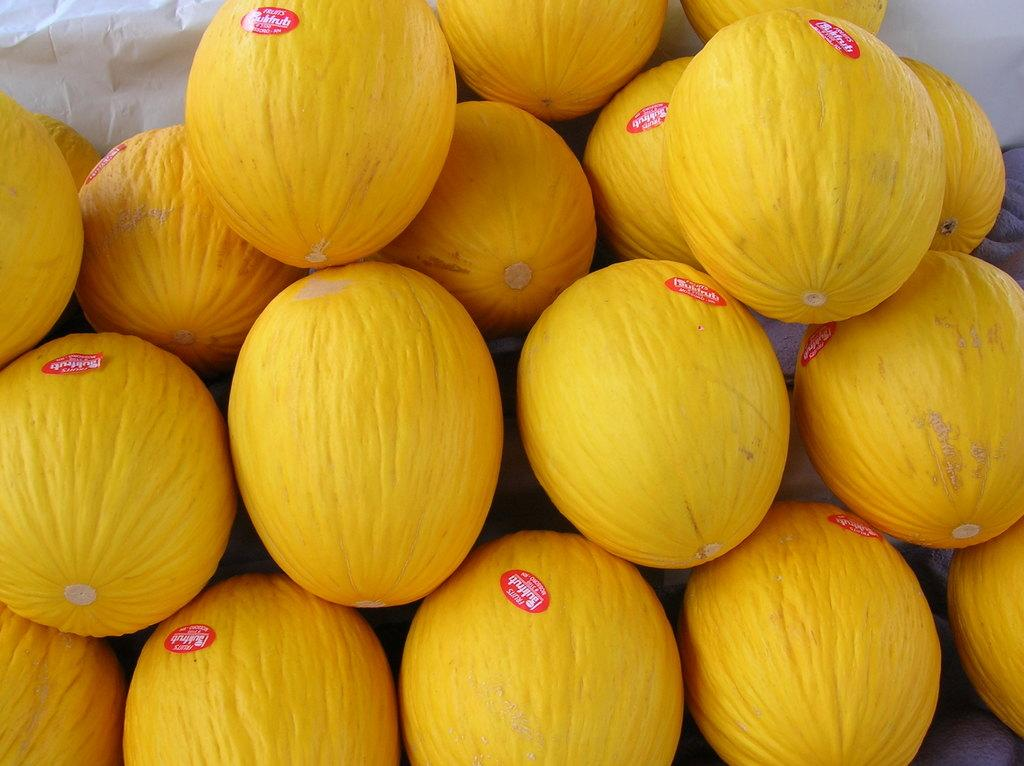What type of fruit is present in the image? There are melons in the image. What color are the stickers visible in the image? The stickers in the image are red. Can you describe the white color object in the background of the image? Unfortunately, the facts provided do not give enough information to describe the white color object in the background. How many girls are present in the image? There are no girls present in the image; it only features melons and red color stickers. Can you tell me the height of the giraffe in the image? There is no giraffe present in the image; it only features melons and red color stickers. 